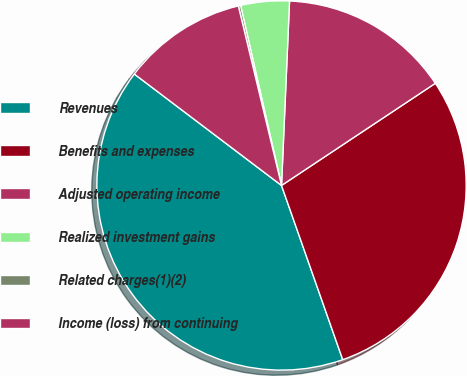Convert chart. <chart><loc_0><loc_0><loc_500><loc_500><pie_chart><fcel>Revenues<fcel>Benefits and expenses<fcel>Adjusted operating income<fcel>Realized investment gains<fcel>Related charges(1)(2)<fcel>Income (loss) from continuing<nl><fcel>40.7%<fcel>28.96%<fcel>14.98%<fcel>4.25%<fcel>0.2%<fcel>10.93%<nl></chart> 